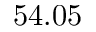Convert formula to latex. <formula><loc_0><loc_0><loc_500><loc_500>5 4 . 0 5</formula> 